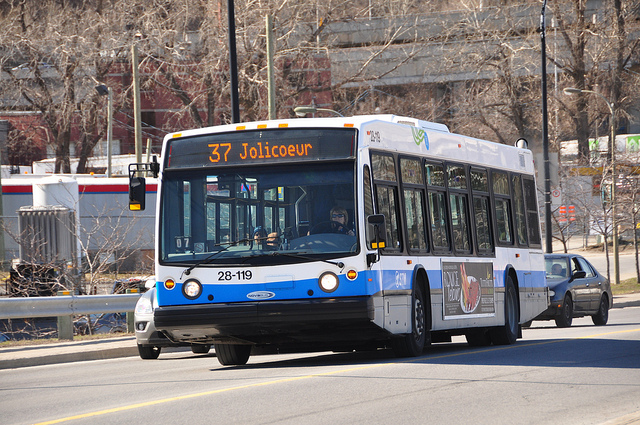Please transcribe the text in this image. 37 Jolicoeur 28 119 